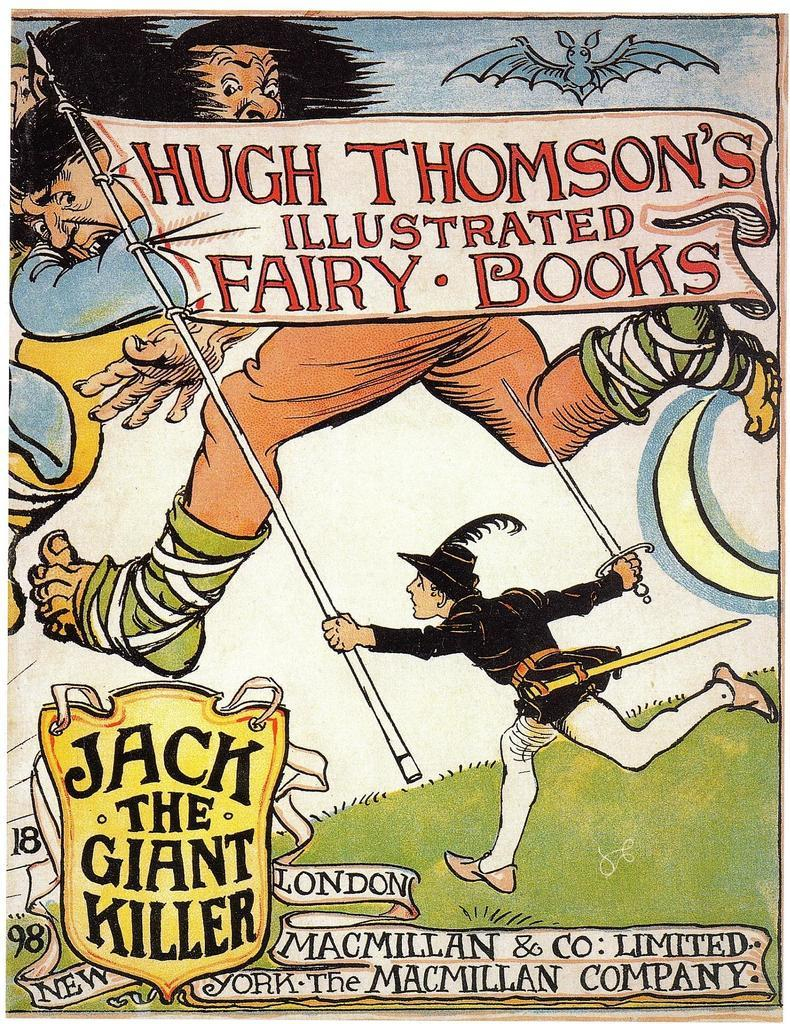<image>
Offer a succinct explanation of the picture presented. The cover of a book by Hugh Thomson is titled Illustrated Fairy Books. 